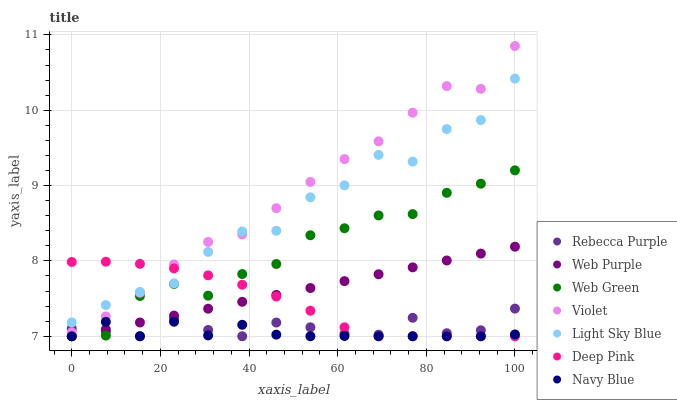Does Navy Blue have the minimum area under the curve?
Answer yes or no. Yes. Does Violet have the maximum area under the curve?
Answer yes or no. Yes. Does Web Green have the minimum area under the curve?
Answer yes or no. No. Does Web Green have the maximum area under the curve?
Answer yes or no. No. Is Web Purple the smoothest?
Answer yes or no. Yes. Is Light Sky Blue the roughest?
Answer yes or no. Yes. Is Navy Blue the smoothest?
Answer yes or no. No. Is Navy Blue the roughest?
Answer yes or no. No. Does Deep Pink have the lowest value?
Answer yes or no. Yes. Does Light Sky Blue have the lowest value?
Answer yes or no. No. Does Violet have the highest value?
Answer yes or no. Yes. Does Web Green have the highest value?
Answer yes or no. No. Is Web Purple less than Violet?
Answer yes or no. Yes. Is Light Sky Blue greater than Web Green?
Answer yes or no. Yes. Does Rebecca Purple intersect Web Purple?
Answer yes or no. Yes. Is Rebecca Purple less than Web Purple?
Answer yes or no. No. Is Rebecca Purple greater than Web Purple?
Answer yes or no. No. Does Web Purple intersect Violet?
Answer yes or no. No. 